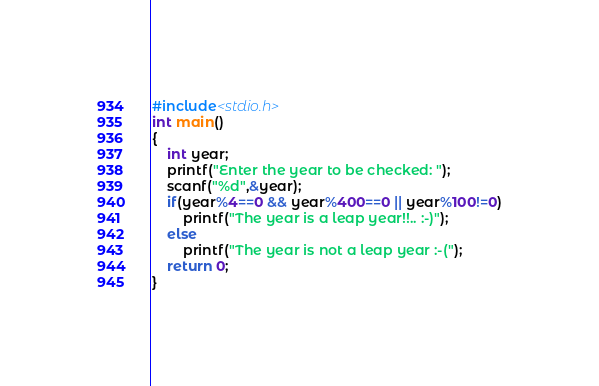Convert code to text. <code><loc_0><loc_0><loc_500><loc_500><_C_>#include<stdio.h>
int main()
{
	int year;
	printf("Enter the year to be checked: ");
	scanf("%d",&year);
	if(year%4==0 && year%400==0 || year%100!=0)
		printf("The year is a leap year!!.. :-)");
	else
		printf("The year is not a leap year :-(");
	return 0;
}
</code> 